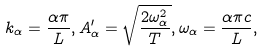<formula> <loc_0><loc_0><loc_500><loc_500>k _ { \alpha } = \frac { \alpha \pi } { L } , A ^ { \prime } _ { \alpha } = \sqrt { \frac { 2 \omega _ { \alpha } ^ { 2 } } { T } } , \omega _ { \alpha } = \frac { \alpha \pi c } { L } ,</formula> 